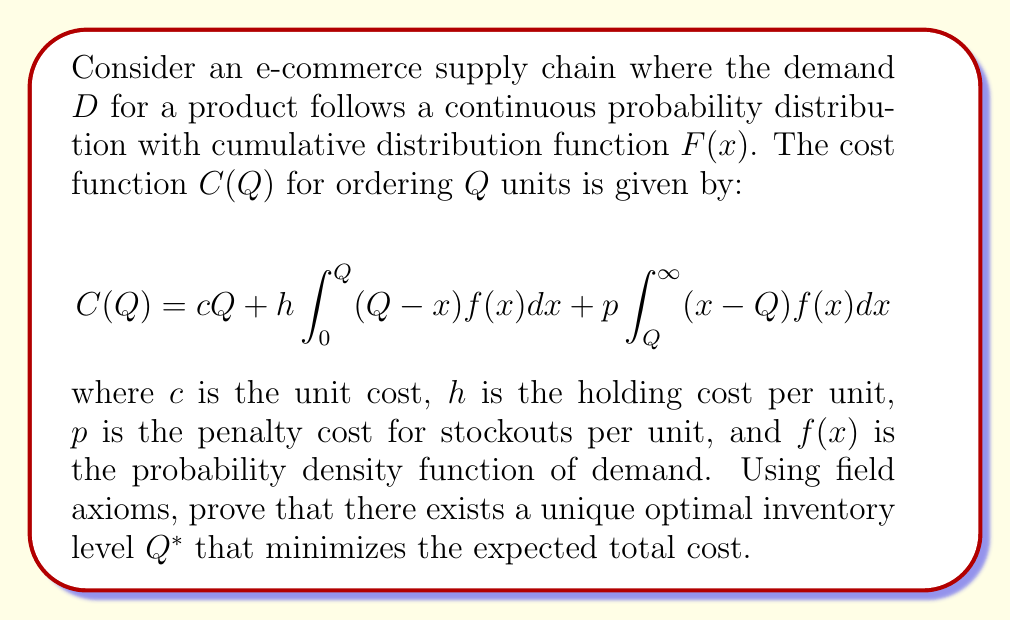Could you help me with this problem? To prove the existence of a unique optimal inventory level using field axioms, we'll follow these steps:

1) First, we need to show that the cost function $C(Q)$ is continuous and differentiable. This follows from the properties of integrals and the assumption that $F(x)$ is continuous.

2) Next, we'll find the first derivative of $C(Q)$ with respect to $Q$:

   $$\frac{dC(Q)}{dQ} = c + h\int_0^Q f(x)dx - p\int_Q^\infty f(x)dx$$

3) Simplify using the properties of cumulative distribution functions:

   $$\frac{dC(Q)}{dQ} = c + hF(Q) - p[1-F(Q)] = c + (h+p)F(Q) - p$$

4) To find the optimal $Q^*$, we set the derivative to zero:

   $$c + (h+p)F(Q^*) - p = 0$$

5) Solving for $F(Q^*)$:

   $$F(Q^*) = \frac{p-c}{h+p}$$

6) The existence of $Q^*$ is guaranteed by the Intermediate Value Theorem, as $F(x)$ is continuous and ranges from 0 to 1.

7) To prove uniqueness, we need to show that the second derivative is always positive:

   $$\frac{d^2C(Q)}{dQ^2} = (h+p)f(Q) > 0$$

   This is true because $h$, $p$, and $f(Q)$ are all positive.

8) The positive second derivative implies that $C(Q)$ is strictly convex, which guarantees a unique global minimum.

Therefore, by the field axioms of real numbers and the properties of continuous functions, we have proved the existence and uniqueness of the optimal inventory level $Q^*$.
Answer: $Q^* = F^{-1}(\frac{p-c}{h+p})$ 